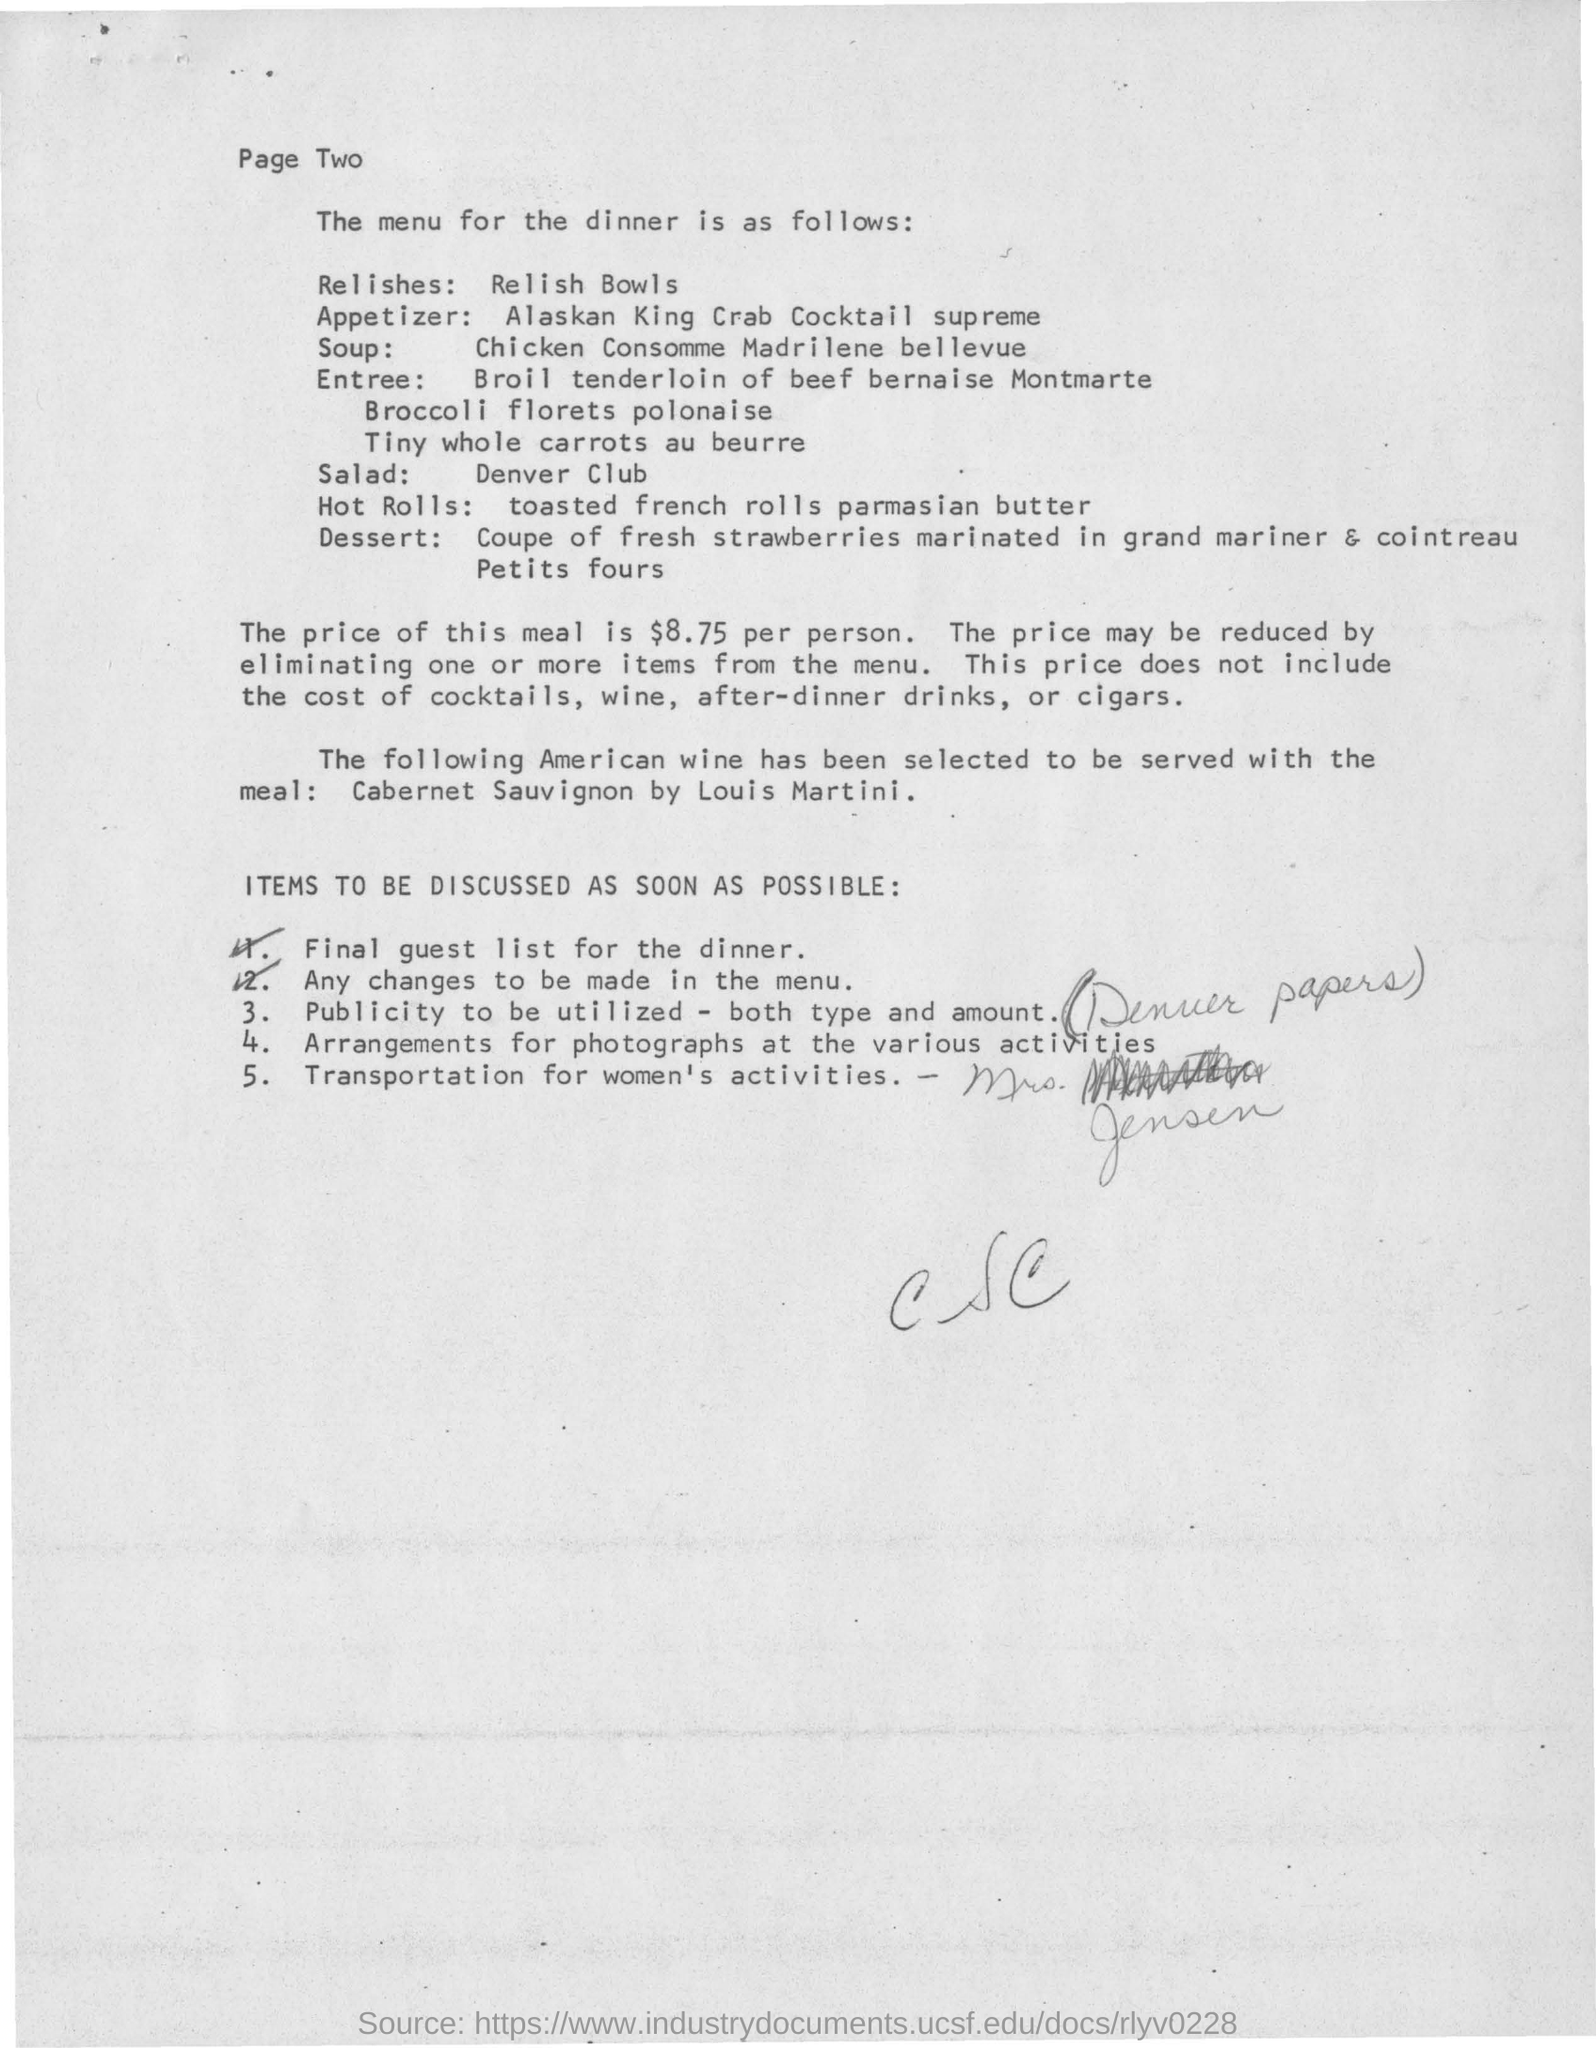Draw attention to some important aspects in this diagram. Removing items from the menu can result in a reduction of prices. The menu for dinner features a chicken consomme Madrid-style from Bellevue. The price of the meal does not include the cost of cocktails, wine, after-dinner drinks, or cigars. After the main course, we will be serving a dessert of fresh strawberries marinated in Grand Mariner and Cointreau. This will be followed by petit fours to complete the meal. The price of dinner at the menu is $8.75 per person. 